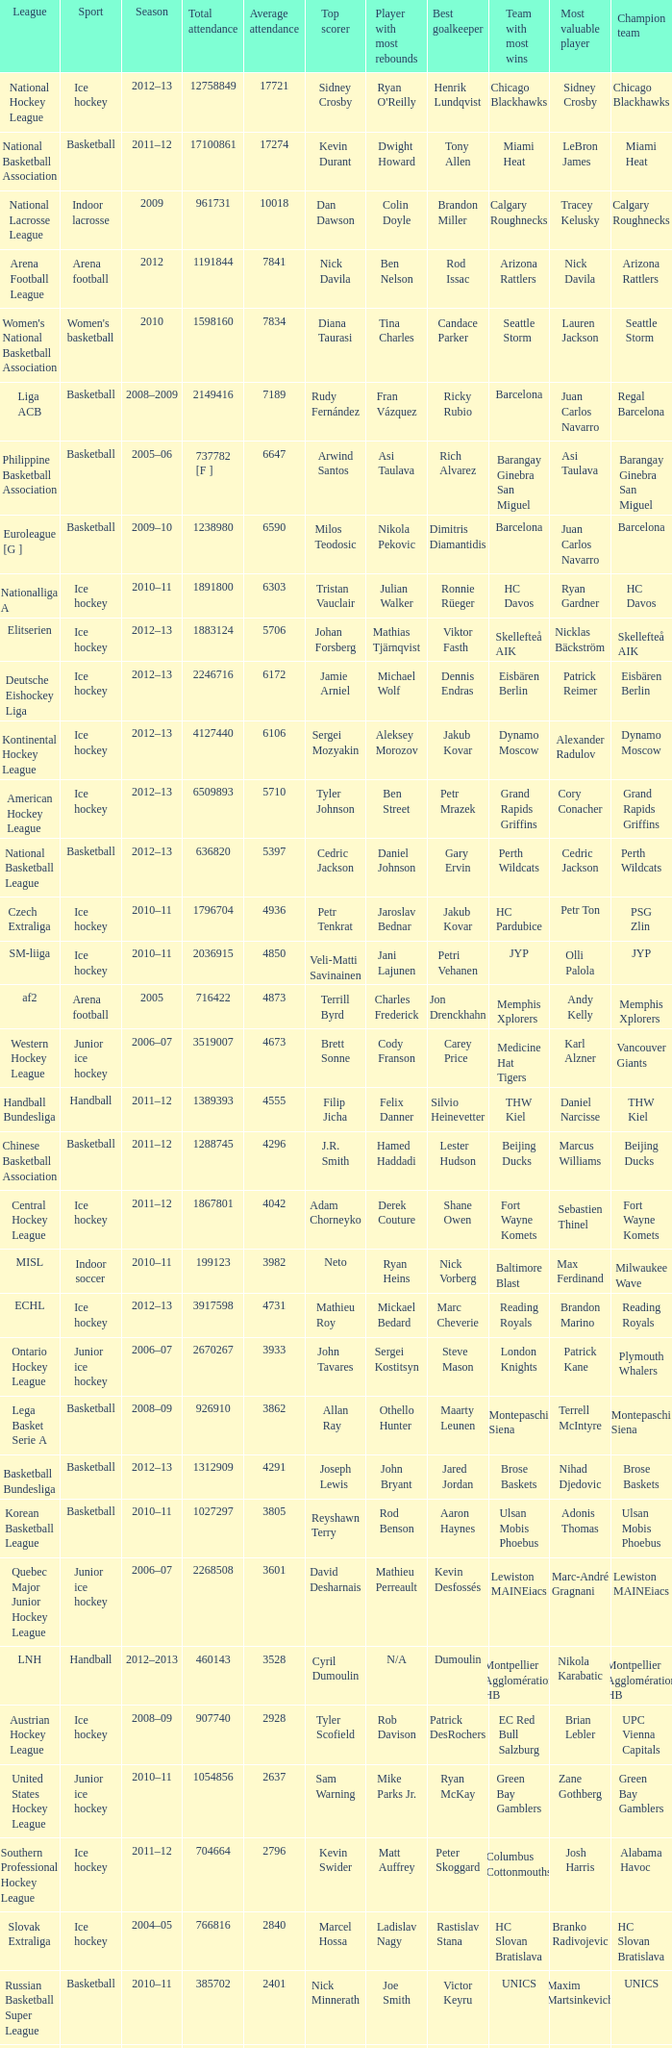What was the highest average attendance in the 2009 season? 10018.0. 